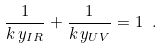<formula> <loc_0><loc_0><loc_500><loc_500>\frac { 1 } { k \, y _ { I R } } + \frac { 1 } { k \, y _ { U V } } = 1 \ .</formula> 